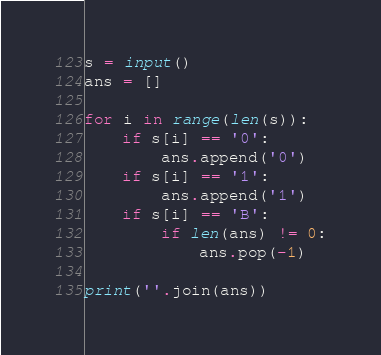<code> <loc_0><loc_0><loc_500><loc_500><_Python_>s = input()
ans = []

for i in range(len(s)):
    if s[i] == '0':
        ans.append('0')
    if s[i] == '1':
        ans.append('1')
    if s[i] == 'B':
        if len(ans) != 0:
            ans.pop(-1)

print(''.join(ans))
</code> 